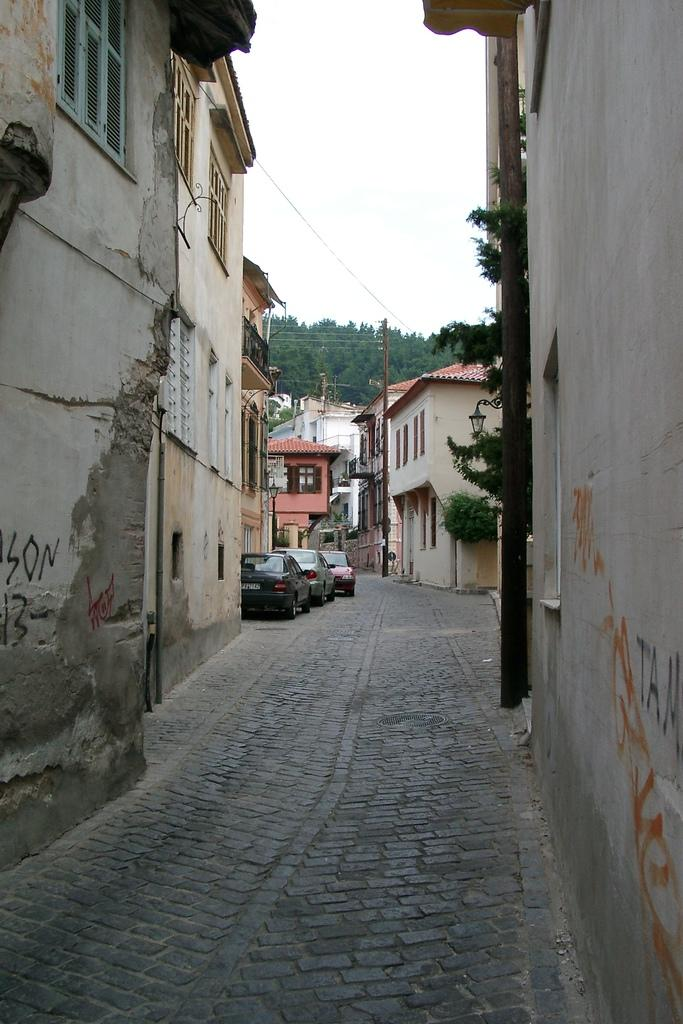What type of structures can be seen in the image? There are buildings in the image. What else can be seen in the background of the image? There are poles, trees, and cars in the background of the image. Can you describe a specific feature on a wall in the image? There is a pipe on a wall in the image. What type of yam is being used to respect the brush in the image? There is no yam, respect, or brush present in the image. 